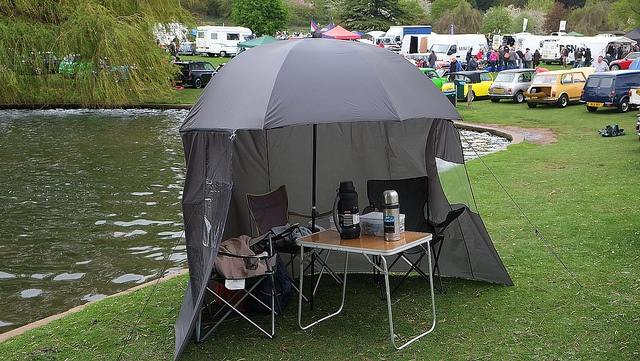Describe the objects in this image and their specific colors. I can see umbrella in darkgreen, darkgray, and gray tones, dining table in darkgreen, black, gray, and darkgray tones, chair in darkgreen, black, gray, and darkgray tones, people in darkgreen, lightgray, gray, darkgray, and black tones, and chair in darkgreen, black, and gray tones in this image. 